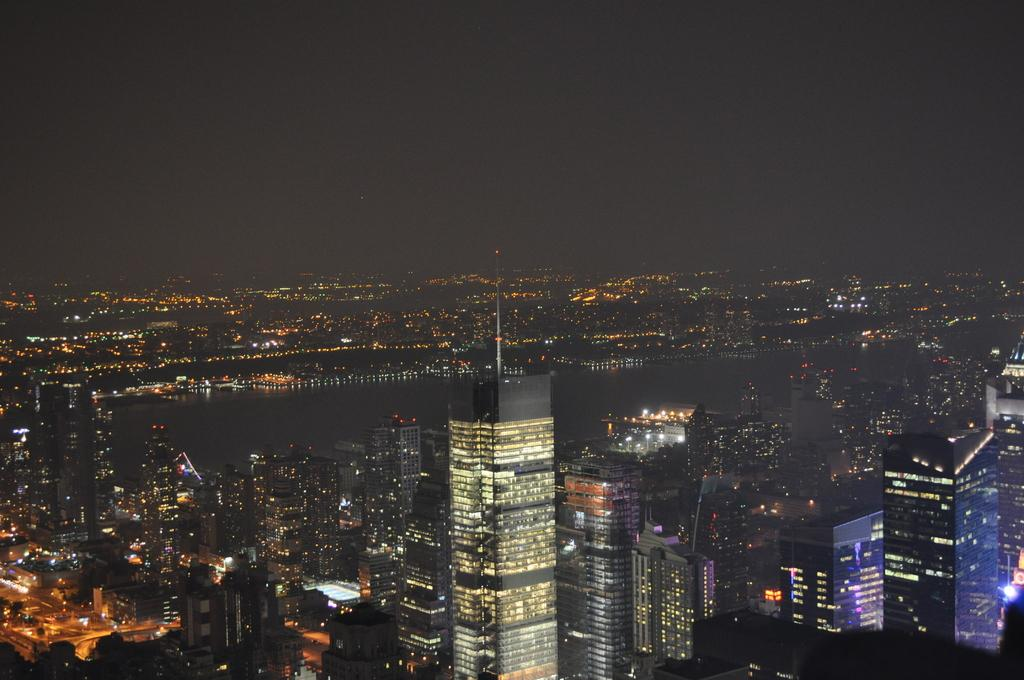What type of structures can be seen in the image? There are buildings in the image. What else is visible besides the buildings? There are lights and water visible in the image. What is the color of the sky in the background of the image? The sky is dark in the background of the image. What type of toys are being played with in the image? There are no toys present in the image. What is the relationship between the buildings and the water in the image? The provided facts do not mention any relationship between the buildings and the water; they are simply two separate elements visible in the image. 